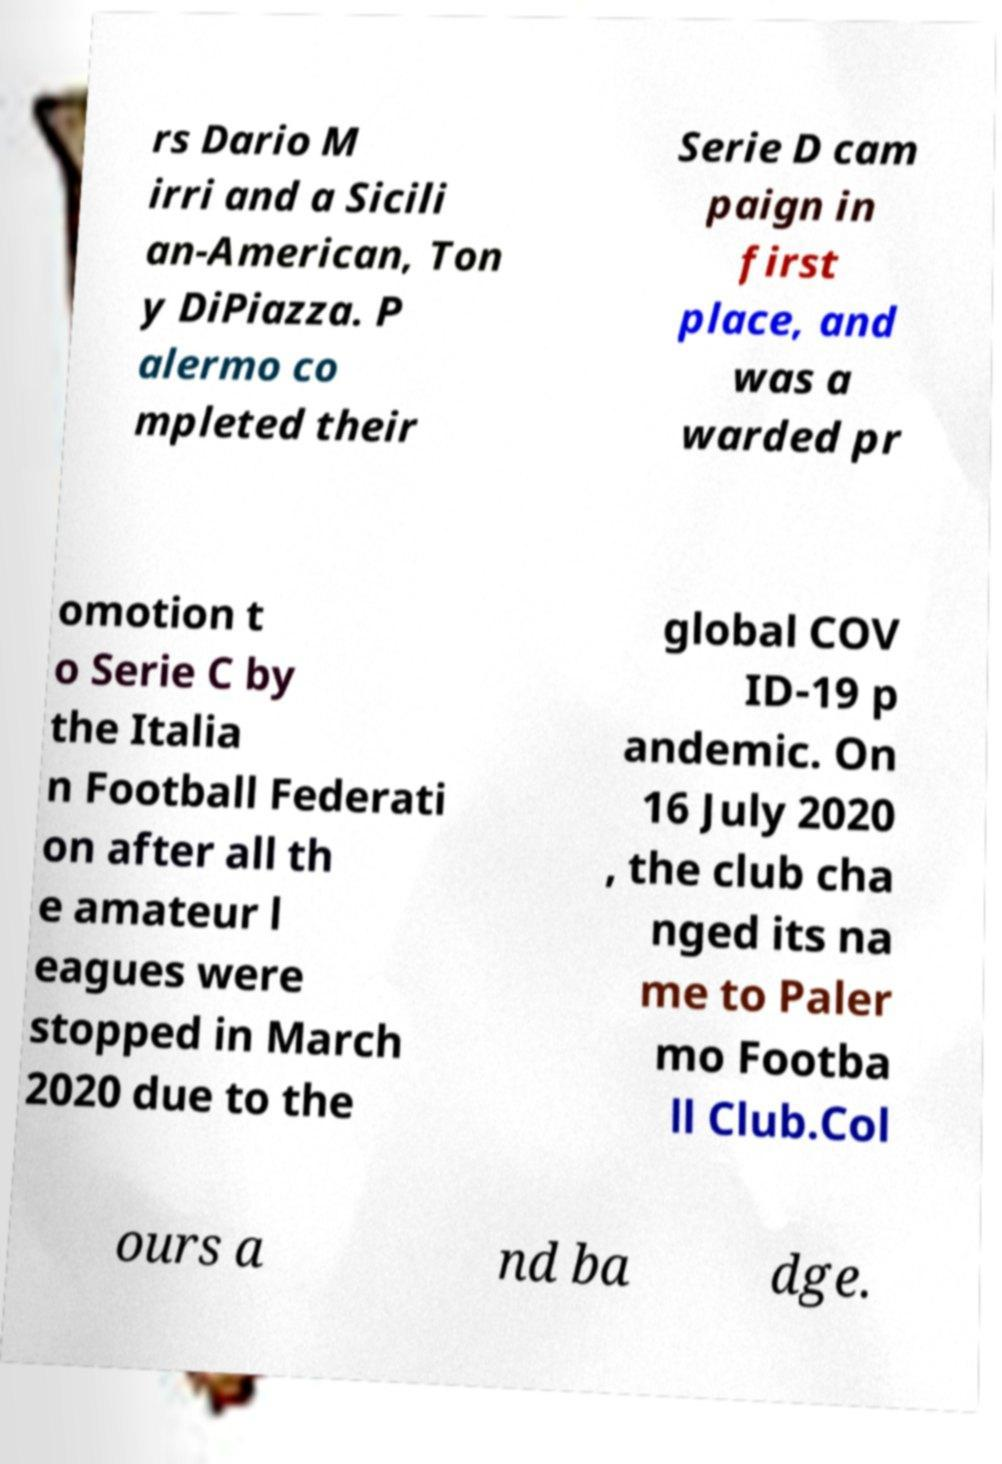Could you extract and type out the text from this image? rs Dario M irri and a Sicili an-American, Ton y DiPiazza. P alermo co mpleted their Serie D cam paign in first place, and was a warded pr omotion t o Serie C by the Italia n Football Federati on after all th e amateur l eagues were stopped in March 2020 due to the global COV ID-19 p andemic. On 16 July 2020 , the club cha nged its na me to Paler mo Footba ll Club.Col ours a nd ba dge. 